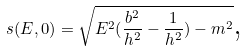Convert formula to latex. <formula><loc_0><loc_0><loc_500><loc_500>s ( E , 0 ) = \sqrt { E ^ { 2 } ( \frac { b ^ { 2 } } { h ^ { 2 } } - \frac { 1 } { h ^ { 2 } } ) - m ^ { 2 } } \text {,}</formula> 